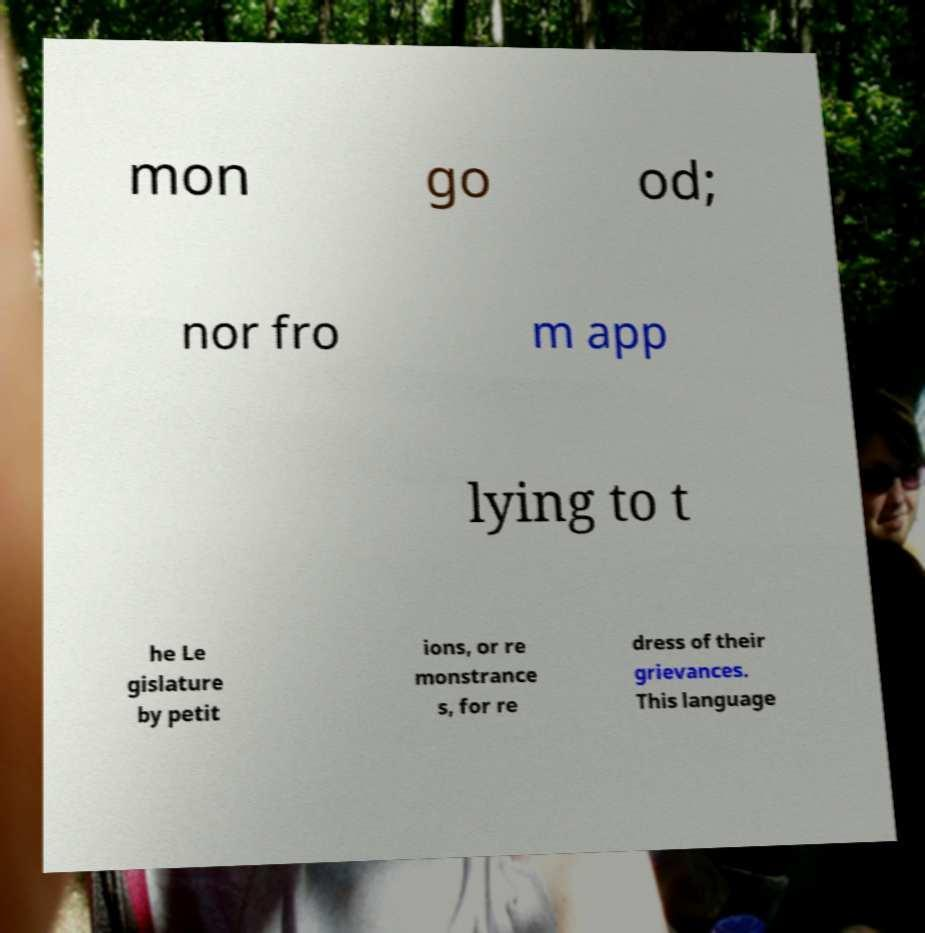Can you accurately transcribe the text from the provided image for me? mon go od; nor fro m app lying to t he Le gislature by petit ions, or re monstrance s, for re dress of their grievances. This language 